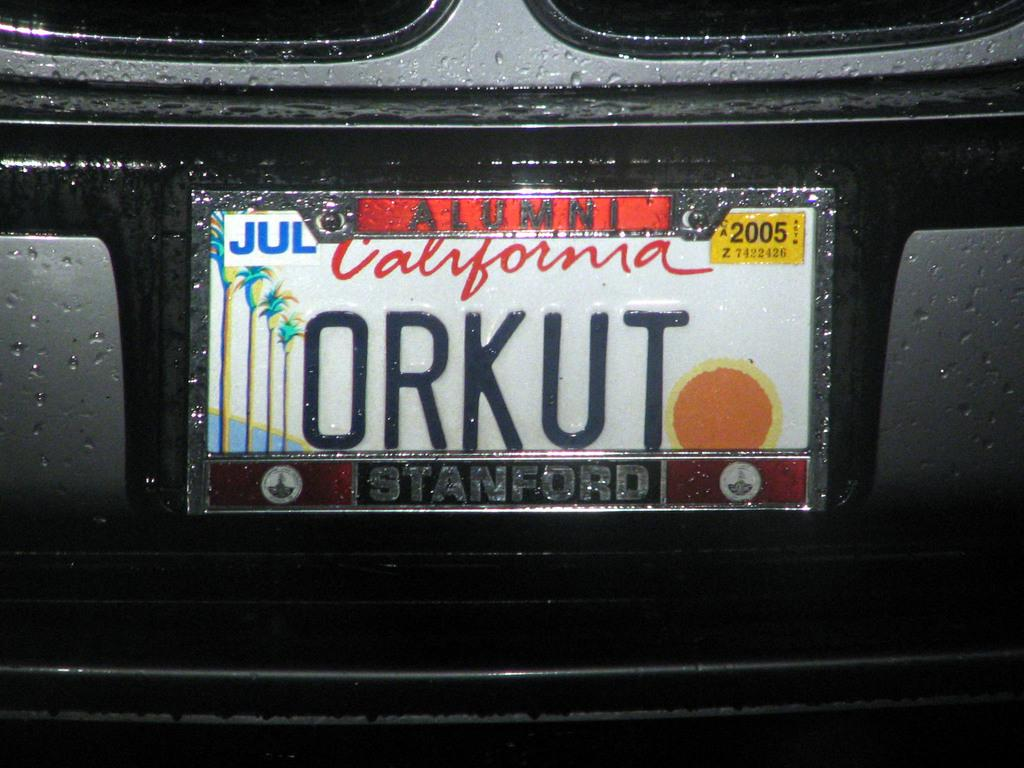<image>
Relay a brief, clear account of the picture shown. White and red California license plate which says ORKUT. 